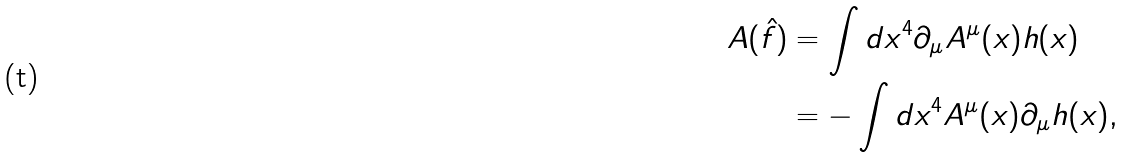Convert formula to latex. <formula><loc_0><loc_0><loc_500><loc_500>A ( \hat { f } ) & = \int d x ^ { 4 } \partial _ { \mu } A ^ { \mu } ( x ) { h } ( x ) \\ & = - \int d x ^ { 4 } A ^ { \mu } ( x ) \partial _ { \mu } { h } ( x ) ,</formula> 